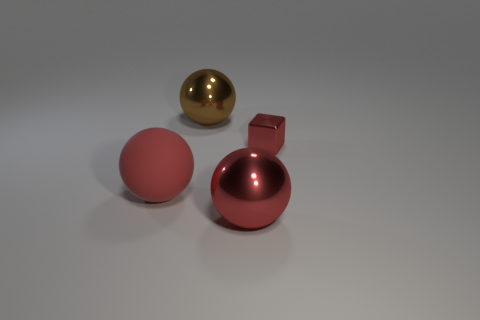Subtract all gray cubes. Subtract all green cylinders. How many cubes are left? 1 Add 2 small red cubes. How many objects exist? 6 Subtract all cubes. How many objects are left? 3 Add 3 small cyan metal balls. How many small cyan metal balls exist? 3 Subtract 0 cyan cubes. How many objects are left? 4 Subtract all green cylinders. Subtract all tiny things. How many objects are left? 3 Add 3 red shiny blocks. How many red shiny blocks are left? 4 